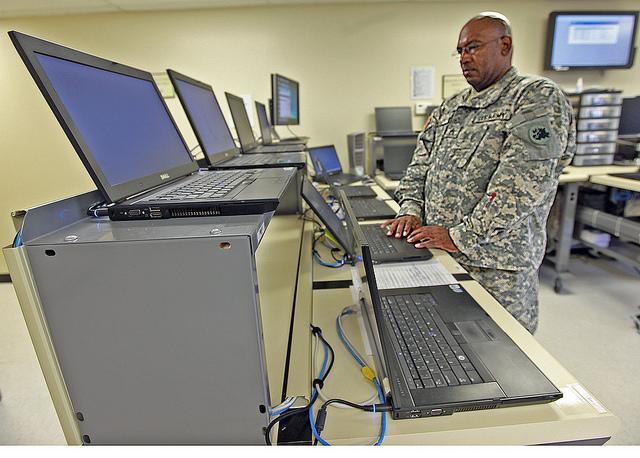How many laptops are visible?
Give a very brief answer. 4. How many elephants can you see it's trunk?
Give a very brief answer. 0. 